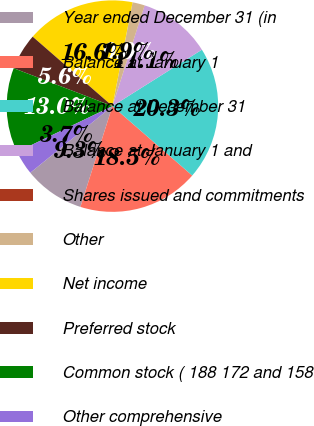Convert chart. <chart><loc_0><loc_0><loc_500><loc_500><pie_chart><fcel>Year ended December 31 (in<fcel>Balance at January 1<fcel>Balance at December 31<fcel>Balance at January 1 and<fcel>Shares issued and commitments<fcel>Other<fcel>Net income<fcel>Preferred stock<fcel>Common stock ( 188 172 and 158<fcel>Other comprehensive<nl><fcel>9.26%<fcel>18.5%<fcel>20.35%<fcel>11.11%<fcel>0.02%<fcel>1.87%<fcel>16.65%<fcel>5.57%<fcel>12.96%<fcel>3.72%<nl></chart> 